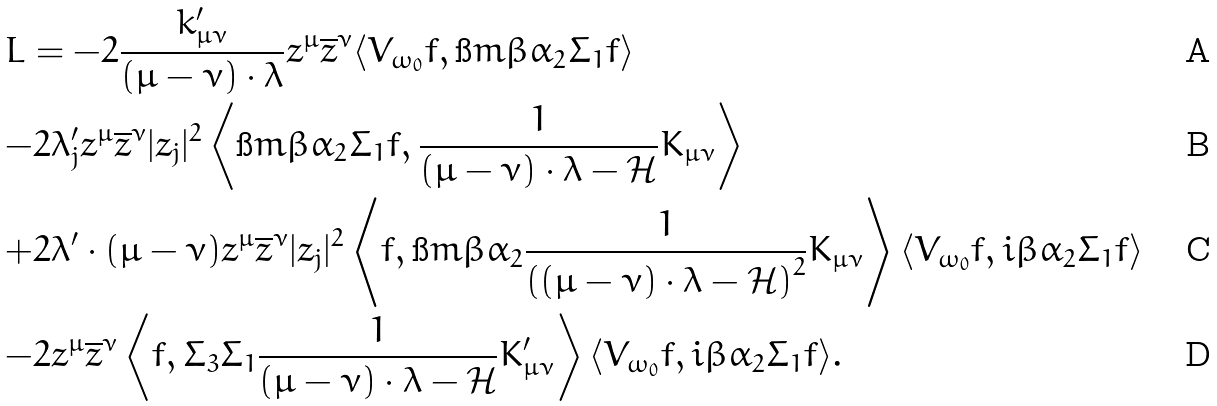Convert formula to latex. <formula><loc_0><loc_0><loc_500><loc_500>& L = { - } 2 \frac { k _ { \mu \nu } ^ { \prime } } { ( \mu - \nu ) \cdot \lambda } z ^ { \mu } \overline { z } ^ { \nu } \langle V _ { \omega _ { 0 } } f , \i m \beta \alpha _ { 2 } \Sigma _ { 1 } f \rangle \\ & { - } 2 \lambda ^ { \prime } _ { j } z ^ { \mu } \overline { z } ^ { \nu } | z _ { j } | ^ { 2 } \left \langle \i m \beta \alpha _ { 2 } \Sigma _ { 1 } f , \frac { 1 } { ( \mu - \nu ) \cdot \lambda - \mathcal { H } } K _ { \mu \nu } \right \rangle \\ & { + } 2 \lambda ^ { \prime } \cdot ( \mu - \nu ) z ^ { \mu } \overline { z } ^ { \nu } | z _ { j } | ^ { 2 } \left \langle f , \i m \beta \alpha _ { 2 } \frac { 1 } { \left ( ( \mu - \nu ) \cdot \lambda - \mathcal { H } \right ) ^ { 2 } } K _ { \mu \nu } \right \rangle \langle { V _ { \omega _ { 0 } } } f , i \beta \alpha _ { 2 } \Sigma _ { 1 } f \rangle \\ & { - } 2 z ^ { \mu } \overline { z } ^ { \nu } \left \langle f , \Sigma _ { 3 } \Sigma _ { 1 } \frac { 1 } { ( \mu - \nu ) \cdot \lambda - \mathcal { H } } K _ { \mu \nu } ^ { \prime } \right \rangle \langle { V _ { \omega _ { 0 } } } f , i \beta \alpha _ { 2 } \Sigma _ { 1 } f \rangle .</formula> 